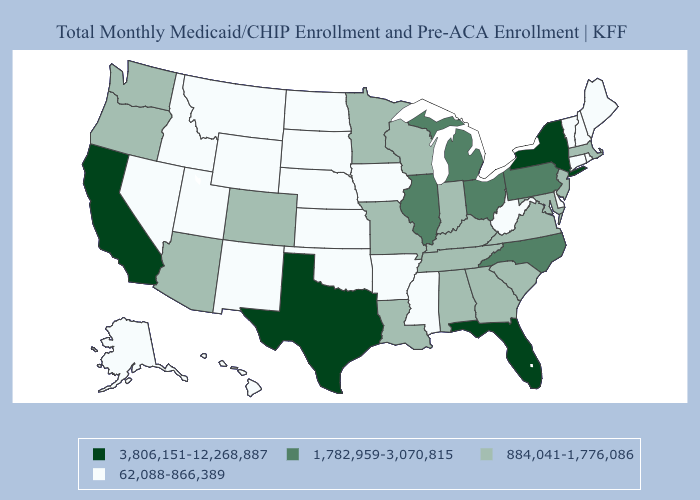Does the map have missing data?
Write a very short answer. No. Does Oklahoma have a lower value than Kansas?
Give a very brief answer. No. Does Michigan have the highest value in the USA?
Give a very brief answer. No. What is the highest value in states that border Maine?
Be succinct. 62,088-866,389. What is the value of West Virginia?
Write a very short answer. 62,088-866,389. Does Pennsylvania have the same value as Wisconsin?
Give a very brief answer. No. Does Utah have a lower value than Michigan?
Short answer required. Yes. What is the highest value in the West ?
Short answer required. 3,806,151-12,268,887. Does the first symbol in the legend represent the smallest category?
Be succinct. No. Among the states that border Michigan , which have the highest value?
Short answer required. Ohio. What is the value of Tennessee?
Give a very brief answer. 884,041-1,776,086. Name the states that have a value in the range 884,041-1,776,086?
Write a very short answer. Alabama, Arizona, Colorado, Georgia, Indiana, Kentucky, Louisiana, Maryland, Massachusetts, Minnesota, Missouri, New Jersey, Oregon, South Carolina, Tennessee, Virginia, Washington, Wisconsin. Name the states that have a value in the range 3,806,151-12,268,887?
Quick response, please. California, Florida, New York, Texas. Does Texas have the highest value in the South?
Short answer required. Yes. What is the value of New Jersey?
Give a very brief answer. 884,041-1,776,086. 